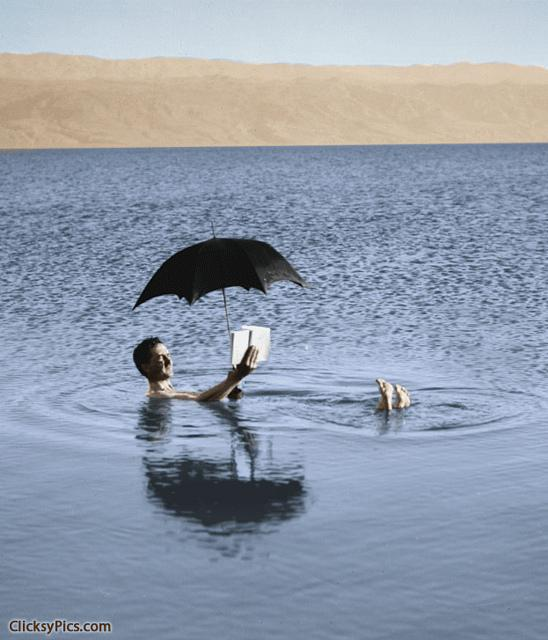Why is the man holding an umbrella? shade 